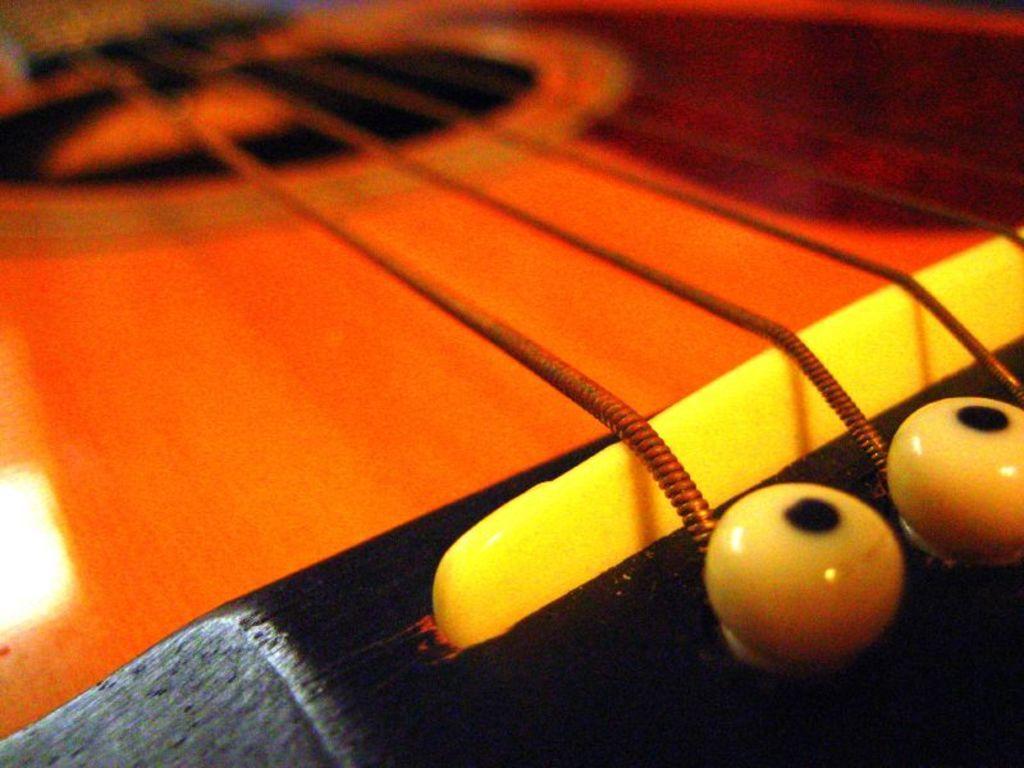In one or two sentences, can you explain what this image depicts? This is the picture where we have the strings of the guitar. 